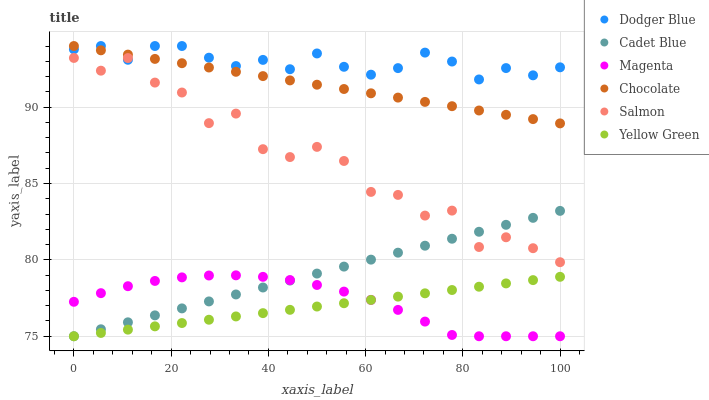Does Yellow Green have the minimum area under the curve?
Answer yes or no. Yes. Does Dodger Blue have the maximum area under the curve?
Answer yes or no. Yes. Does Salmon have the minimum area under the curve?
Answer yes or no. No. Does Salmon have the maximum area under the curve?
Answer yes or no. No. Is Cadet Blue the smoothest?
Answer yes or no. Yes. Is Salmon the roughest?
Answer yes or no. Yes. Is Yellow Green the smoothest?
Answer yes or no. No. Is Yellow Green the roughest?
Answer yes or no. No. Does Cadet Blue have the lowest value?
Answer yes or no. Yes. Does Salmon have the lowest value?
Answer yes or no. No. Does Dodger Blue have the highest value?
Answer yes or no. Yes. Does Salmon have the highest value?
Answer yes or no. No. Is Magenta less than Dodger Blue?
Answer yes or no. Yes. Is Salmon greater than Magenta?
Answer yes or no. Yes. Does Yellow Green intersect Cadet Blue?
Answer yes or no. Yes. Is Yellow Green less than Cadet Blue?
Answer yes or no. No. Is Yellow Green greater than Cadet Blue?
Answer yes or no. No. Does Magenta intersect Dodger Blue?
Answer yes or no. No. 